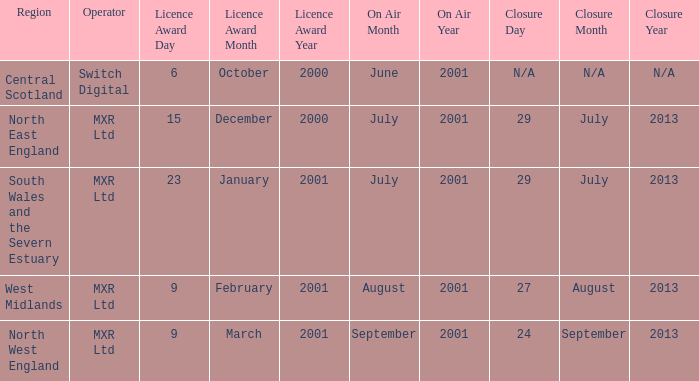What is the license award date for North East England? 15 December 2000. 